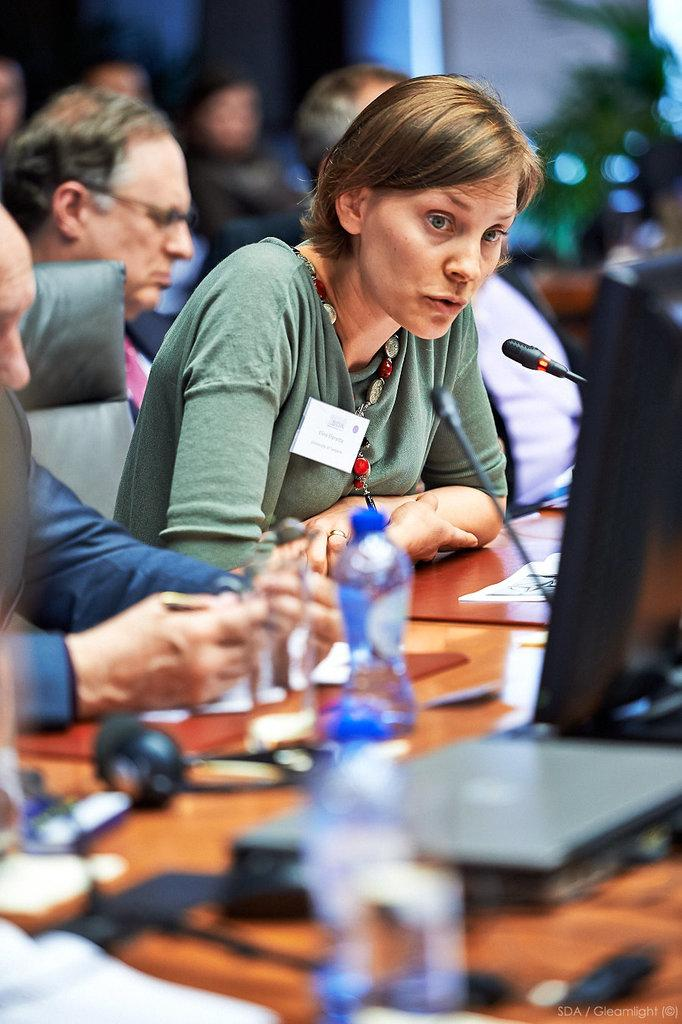What electronic devices can be seen in the image? There are laptops in the image. What type of containers are present in the image? There are bottles in the image. What are the people wearing in the image? The image shows people wearing headsets. Can you describe the other objects on the tables? There are other objects on the tables, but their specific details are not mentioned in the facts. What is present in the bottom right corner of the image? There is a watermark in the bottom right of the image. How many people are visible in the image? There are a few people in the image. What type of lettuce is being served in the hospital cafeteria in the image? There is no hospital or lettuce present in the image. Can you describe the facial expressions of the people in the image? The image does not show the faces of the people, so their facial expressions cannot be described. 